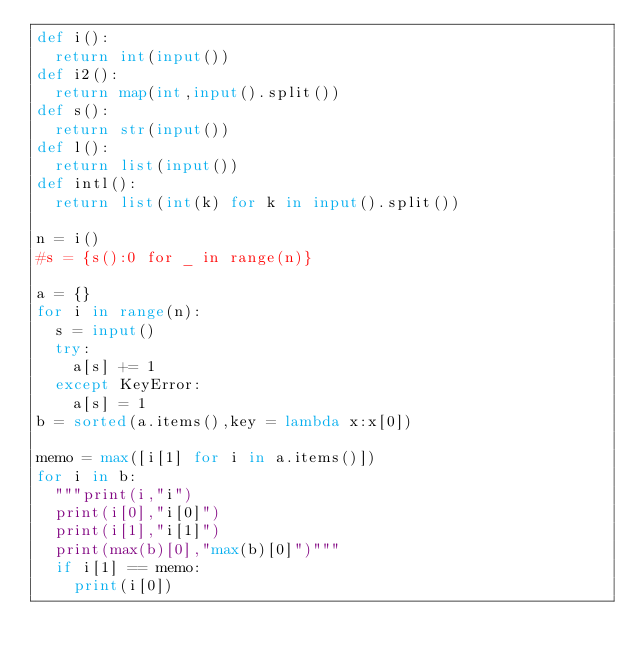<code> <loc_0><loc_0><loc_500><loc_500><_Python_>def i():
	return int(input())
def i2():
	return map(int,input().split())
def s():
	return str(input())
def l():
	return list(input())
def intl():
	return list(int(k) for k in input().split())

n = i()
#s = {s():0 for _ in range(n)}

a = {}
for i in range(n):
	s = input()
	try:
		a[s] += 1
	except KeyError:
		a[s] = 1
b = sorted(a.items(),key = lambda x:x[0])

memo = max([i[1] for i in a.items()])
for i in b:
	"""print(i,"i")
	print(i[0],"i[0]")
	print(i[1],"i[1]")
	print(max(b)[0],"max(b)[0]")"""
	if i[1] == memo:
		print(i[0])
</code> 